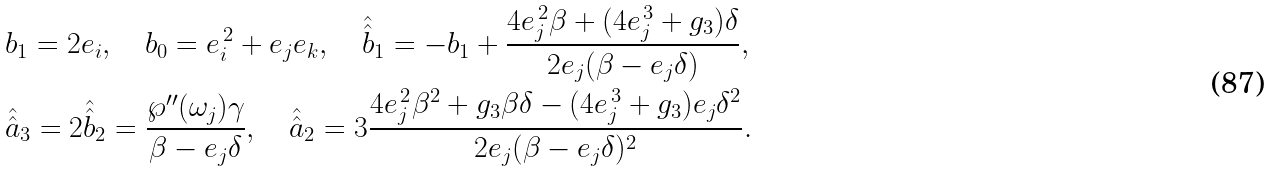<formula> <loc_0><loc_0><loc_500><loc_500>& b _ { 1 } = 2 e _ { i } , \quad b _ { 0 } = e _ { i } ^ { \, 2 } + e _ { j } e _ { k } , \quad \hat { \hat { b } } _ { 1 } = - b _ { 1 } + \frac { 4 e _ { j } ^ { \, 2 } \beta + ( 4 e _ { j } ^ { \, 3 } + g _ { 3 } ) \delta } { 2 e _ { j } ( \beta - e _ { j } \delta ) } , \\ & \hat { \hat { a } } _ { 3 } = 2 \hat { \hat { b } } _ { 2 } = \frac { \wp ^ { \prime \prime } ( \omega _ { j } ) \gamma } { \beta - e _ { j } \delta } , \quad \hat { \hat { a } } _ { 2 } = 3 \frac { 4 e _ { j } ^ { \, 2 } \beta ^ { 2 } + g _ { 3 } \beta \delta - ( 4 e _ { j } ^ { \, 3 } + g _ { 3 } ) e _ { j } \delta ^ { 2 } } { 2 e _ { j } ( \beta - e _ { j } \delta ) ^ { 2 } } .</formula> 